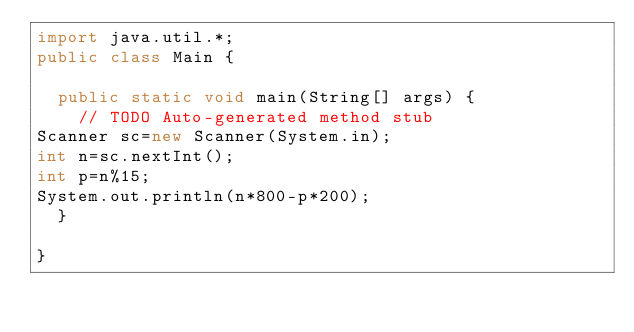Convert code to text. <code><loc_0><loc_0><loc_500><loc_500><_Java_>import java.util.*;
public class Main {

	public static void main(String[] args) {
		// TODO Auto-generated method stub
Scanner sc=new Scanner(System.in);
int n=sc.nextInt();
int p=n%15;
System.out.println(n*800-p*200);
	}

}
</code> 